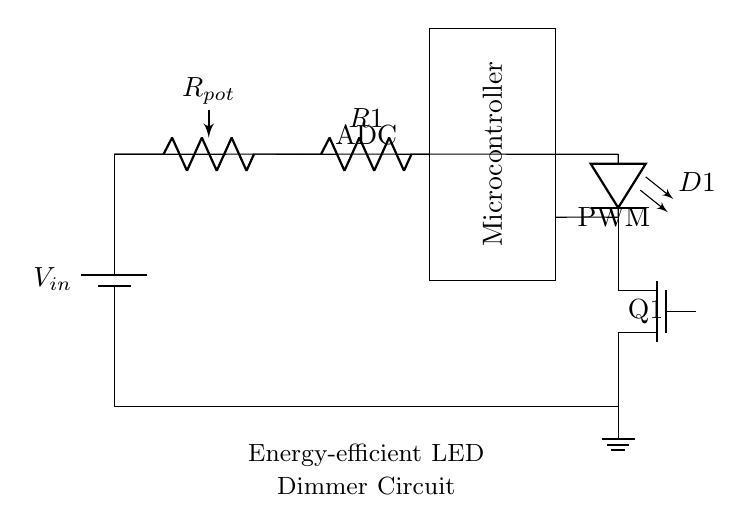What type of transistor is used in the circuit? The circuit diagram shows a Tnmos symbol, indicating that a N-channel MOSFET is used as the transistor for switching the LED.
Answer: N-channel MOSFET What component limits the current to the LED? In the circuit, the component labeled R1 is a resistor that limits the current flowing through the LED D1, preventing it from drawing too much current.
Answer: Resistor What function does the microcontroller serve in the circuit? The microcontroller processes the input from the potentiometer through its ADC and generates a PWM signal to control the brightness of the LED.
Answer: Control How is the LED connected in the circuit? The LED, D1, is connected in series with the current limiting resistor and the MOSFET, allowing current to flow through the LED when the MOSFET is turned on by the PWM signal.
Answer: In series What is the purpose of the potentiometer in the circuit? The potentiometer acts as an adjustable resistor that allows the user to change the resistance, which modifies the voltage seen by the microcontroller's ADC, thus varying the dimming level of the LED.
Answer: Adjust brightness 